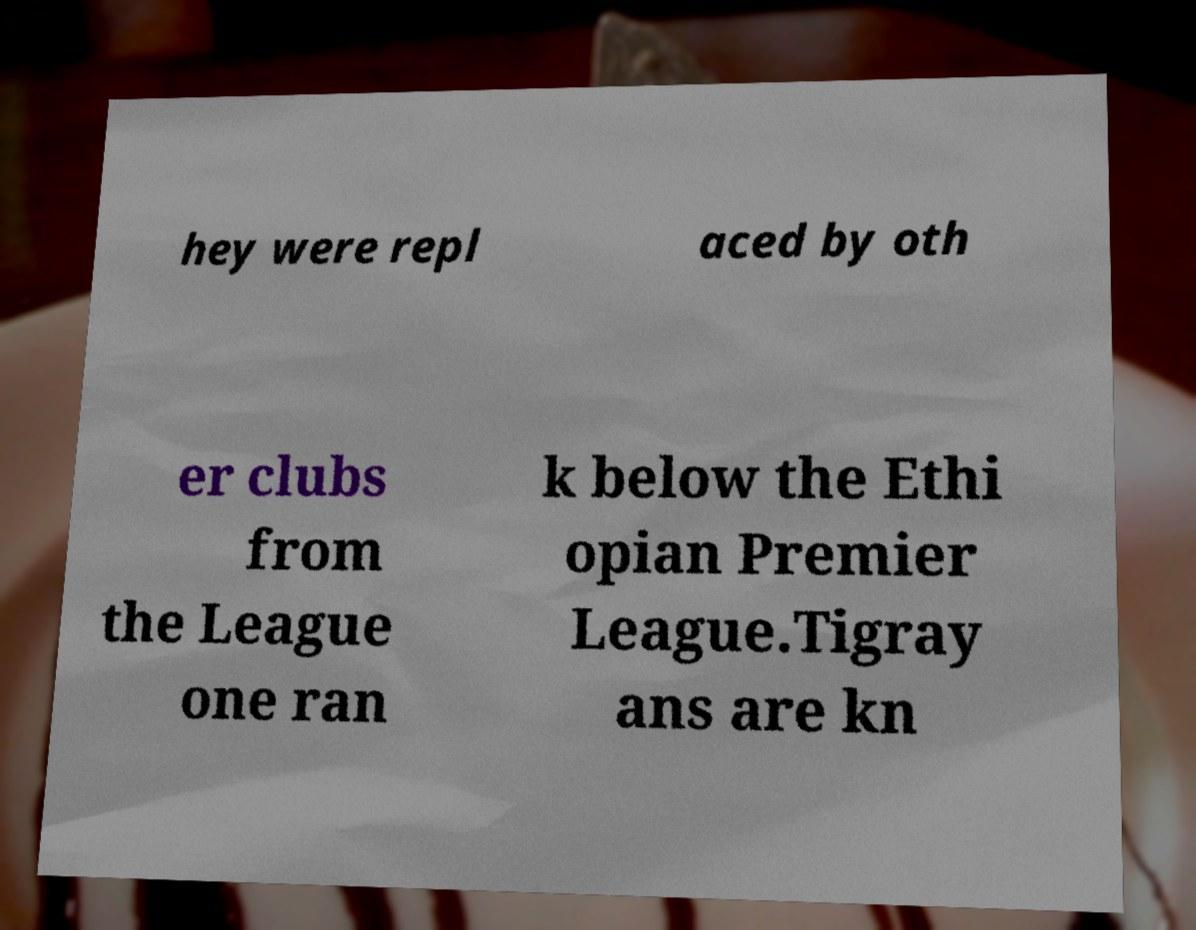Can you accurately transcribe the text from the provided image for me? hey were repl aced by oth er clubs from the League one ran k below the Ethi opian Premier League.Tigray ans are kn 